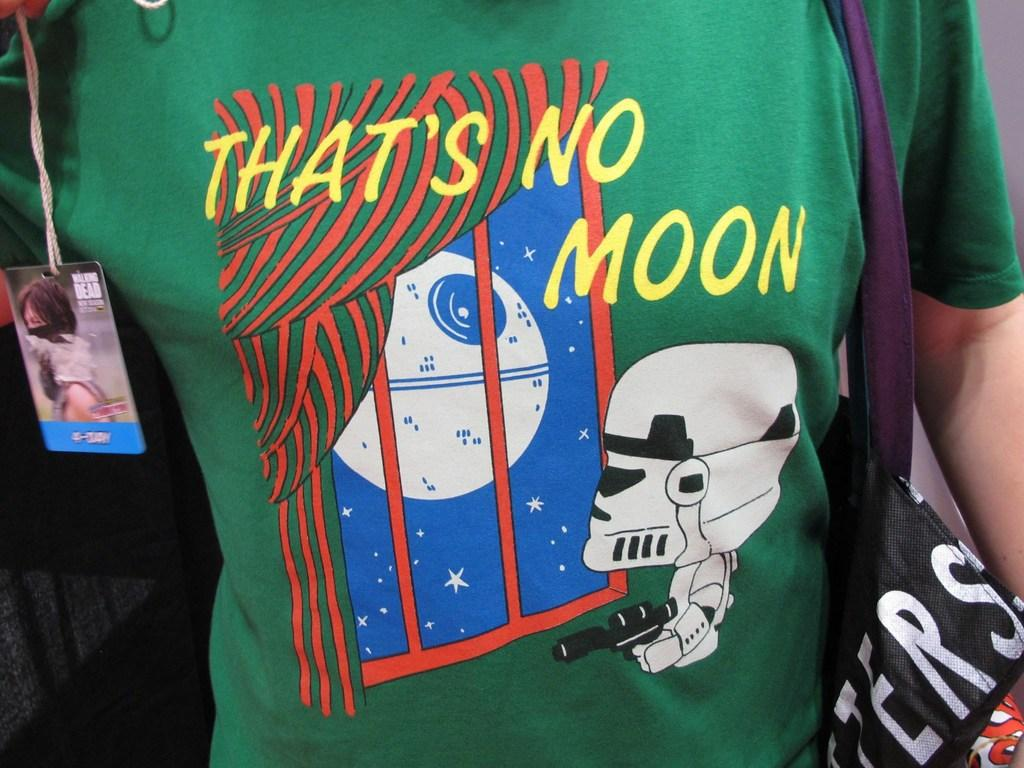<image>
Summarize the visual content of the image. That's No Moon is written in yellow on the green t-shirt. 